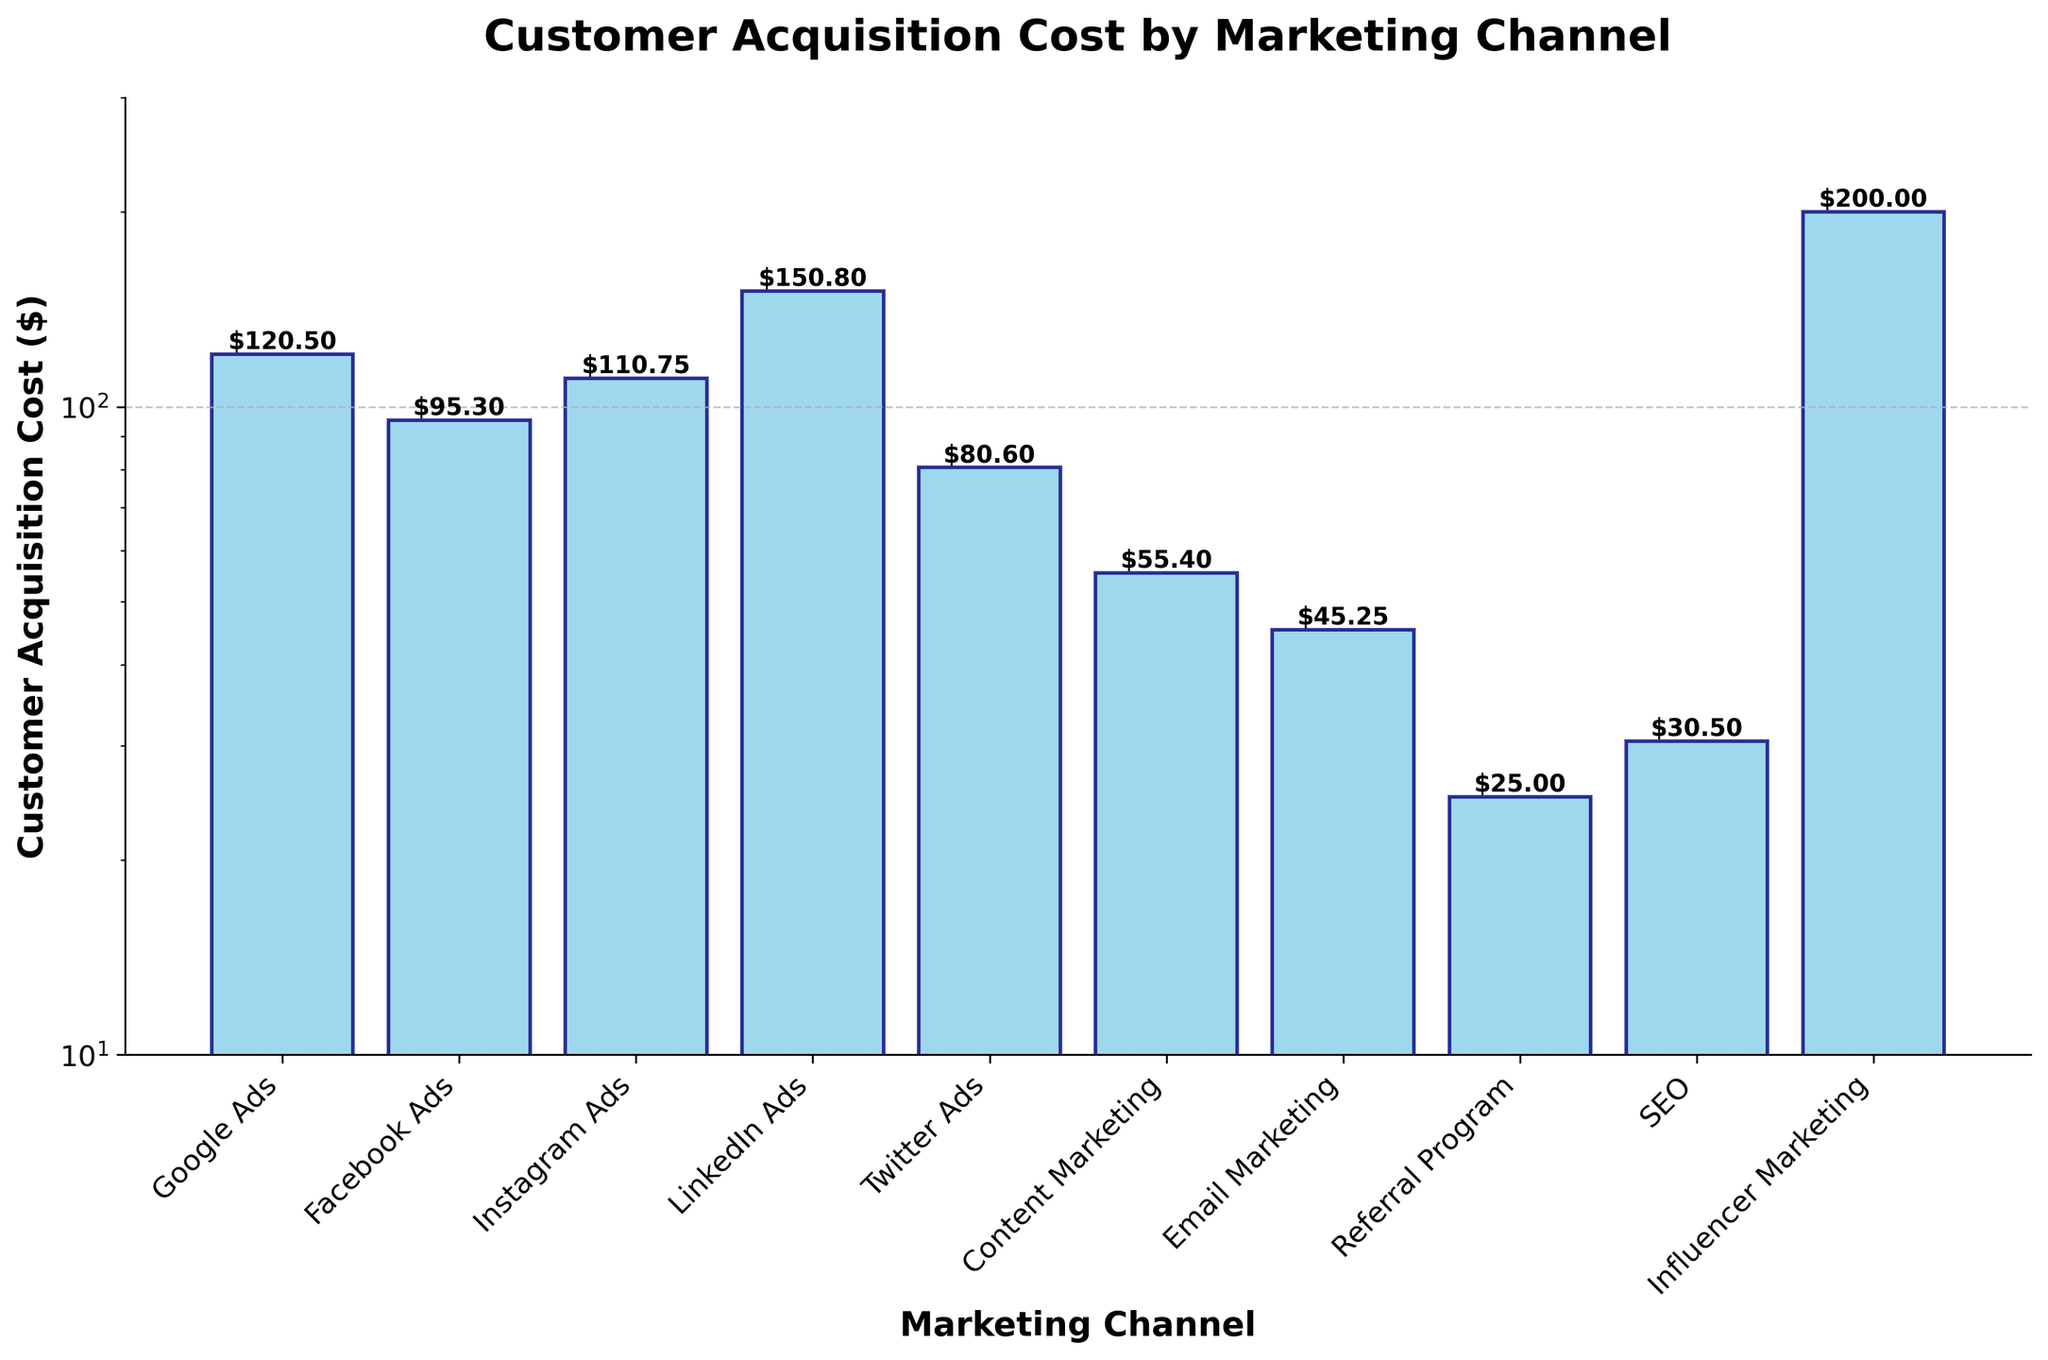What is the Customer Acquisition Cost for LinkedIn Ads? The bar for LinkedIn Ads indicates a Customer Acquisition Cost of $150.80.
Answer: $150.80 Which marketing channel has the lowest Customer Acquisition Cost? The bar for Email Marketing is the lowest, indicating a Cost of $45.25.
Answer: Email Marketing How many marketing channels have a Customer Acquisition Cost greater than $100? The bars for Google Ads, Instagram Ads, LinkedIn Ads, and Influencer Marketing have heights above the $100 line, so there are 4 channels.
Answer: 4 What is the title of the plot? The title of the plot is clearly written at the top as "Customer Acquisition Cost by Marketing Channel".
Answer: Customer Acquisition Cost by Marketing Channel What is the total Customer Acquisition Cost for Google Ads and Facebook Ads combined? Google Ads has a cost of $120.50 and Facebook Ads has a cost of $95.30, so the total is $120.50 + $95.30 = $215.80.
Answer: $215.80 Is the Customer Acquisition Cost for Influencer Marketing higher or lower than LinkedIn Ads? The bar for Influencer Marketing is higher than the bar for LinkedIn Ads, indicating a higher cost.
Answer: Higher What is the difference in Customer Acquisition Cost between Twitter Ads and SEO? Twitter Ads have a cost of $80.60 and SEO has a cost of $30.50, so the difference is $80.60 - $30.50 = $50.10.
Answer: $50.10 Which marketing channels have a Customer Acquisition Cost between $50 and $100? The bars for Facebook Ads, Twitter Ads, and Content Marketing fall within the range of $50 to $100.
Answer: Facebook Ads, Twitter Ads, Content Marketing Does the plot use a linear or logarithmic scale for the y-axis? The y-axis is labeled with values that increase exponentially (10, 100), indicating that a logarithmic scale is used.
Answer: Logarithmic What is the ratio of the highest Customer Acquisition Cost to the lowest? The highest cost is for Influencer Marketing at $200.00, and the lowest is for Referral Program at $25.00, so the ratio is $200.00 / $25.00 = 8.
Answer: 8 